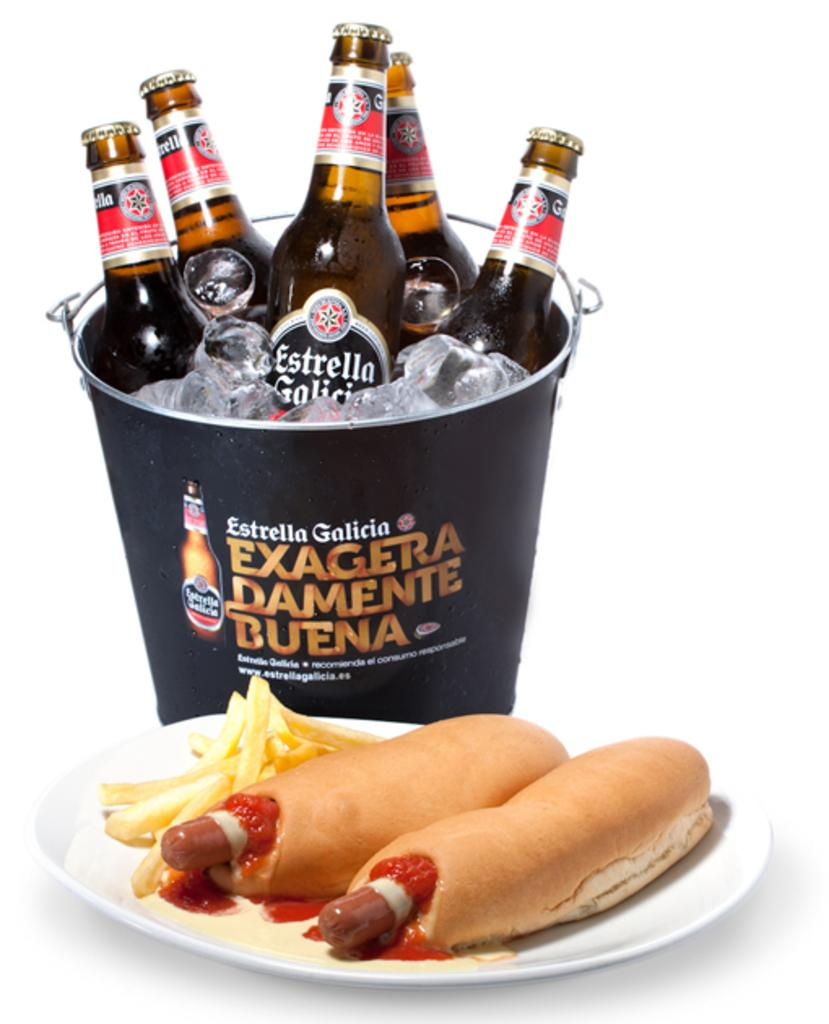What is on the plate that is visible in the image? There is a plate with food in the image. What is located behind the plate in the image? There is a bucket behind the plate. What is inside the bucket in the image? The bucket contains ice cubes and bottles. How many icicles are hanging from the plate in the image? There are no icicles present in the image. What type of leather item can be seen on the plate in the image? There is no leather item present on the plate or in the image. 